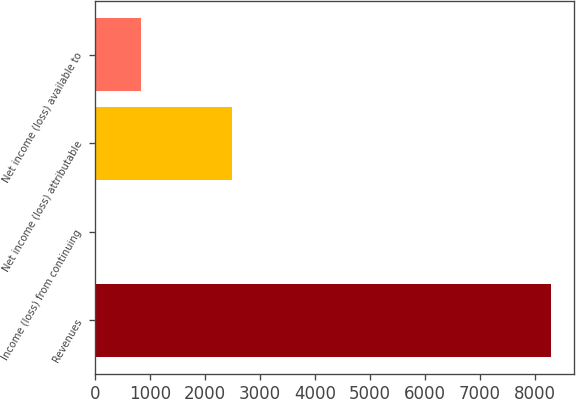Convert chart. <chart><loc_0><loc_0><loc_500><loc_500><bar_chart><fcel>Revenues<fcel>Income (loss) from continuing<fcel>Net income (loss) attributable<fcel>Net income (loss) available to<nl><fcel>8292<fcel>0.28<fcel>2487.79<fcel>829.45<nl></chart> 